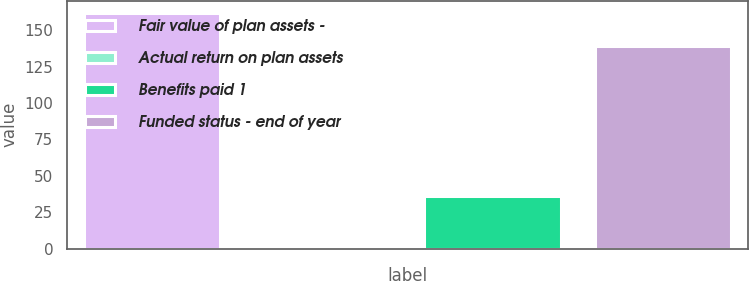Convert chart to OTSL. <chart><loc_0><loc_0><loc_500><loc_500><bar_chart><fcel>Fair value of plan assets -<fcel>Actual return on plan assets<fcel>Benefits paid 1<fcel>Funded status - end of year<nl><fcel>162<fcel>2<fcel>36<fcel>139<nl></chart> 